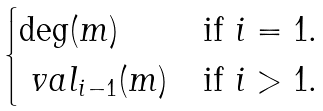Convert formula to latex. <formula><loc_0><loc_0><loc_500><loc_500>\begin{cases} \deg ( m ) & \text {if $i = 1$.} \\ \ v a l _ { i - 1 } ( m ) & \text {if $i > 1$.} \end{cases}</formula> 